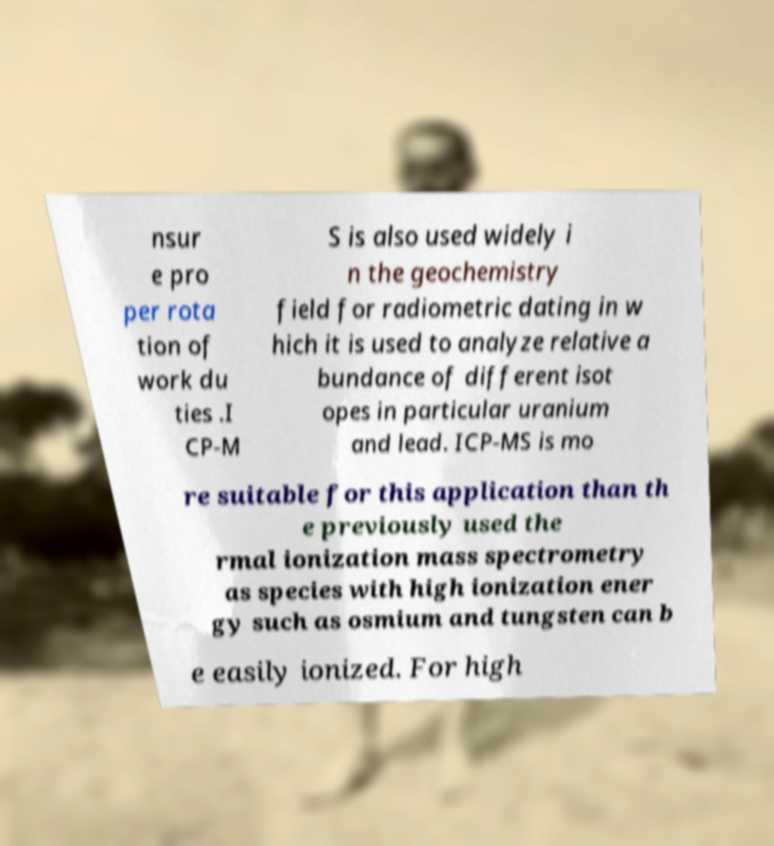Please identify and transcribe the text found in this image. nsur e pro per rota tion of work du ties .I CP-M S is also used widely i n the geochemistry field for radiometric dating in w hich it is used to analyze relative a bundance of different isot opes in particular uranium and lead. ICP-MS is mo re suitable for this application than th e previously used the rmal ionization mass spectrometry as species with high ionization ener gy such as osmium and tungsten can b e easily ionized. For high 